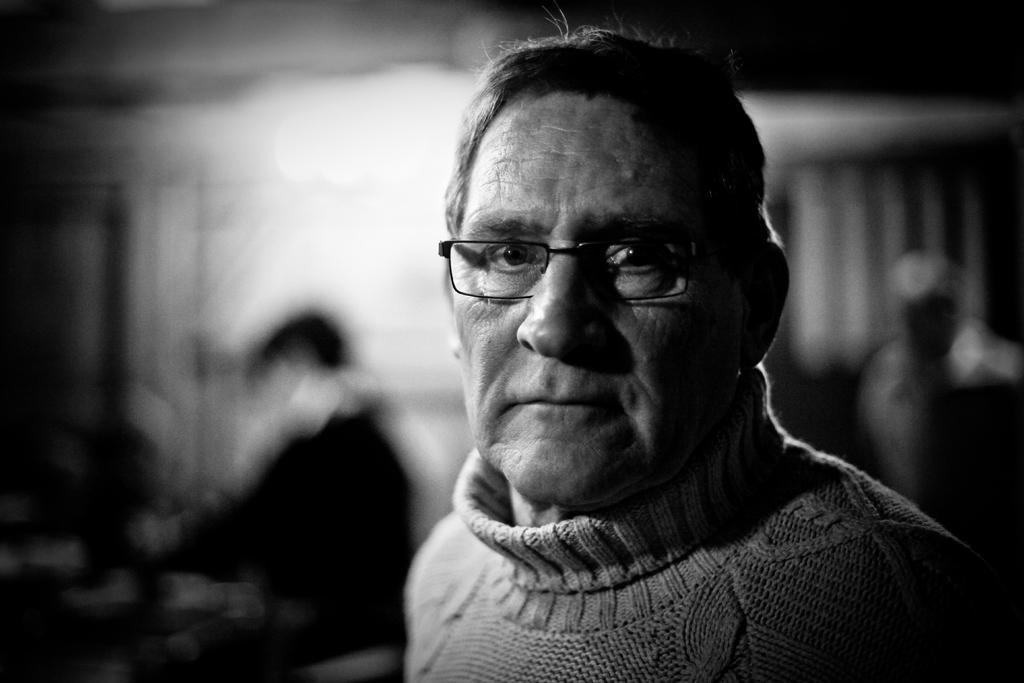Could you give a brief overview of what you see in this image? This is a black and white picture, in this image we can see a person wearing the spectacles, behind him we can see two persons and the background is blurred. 